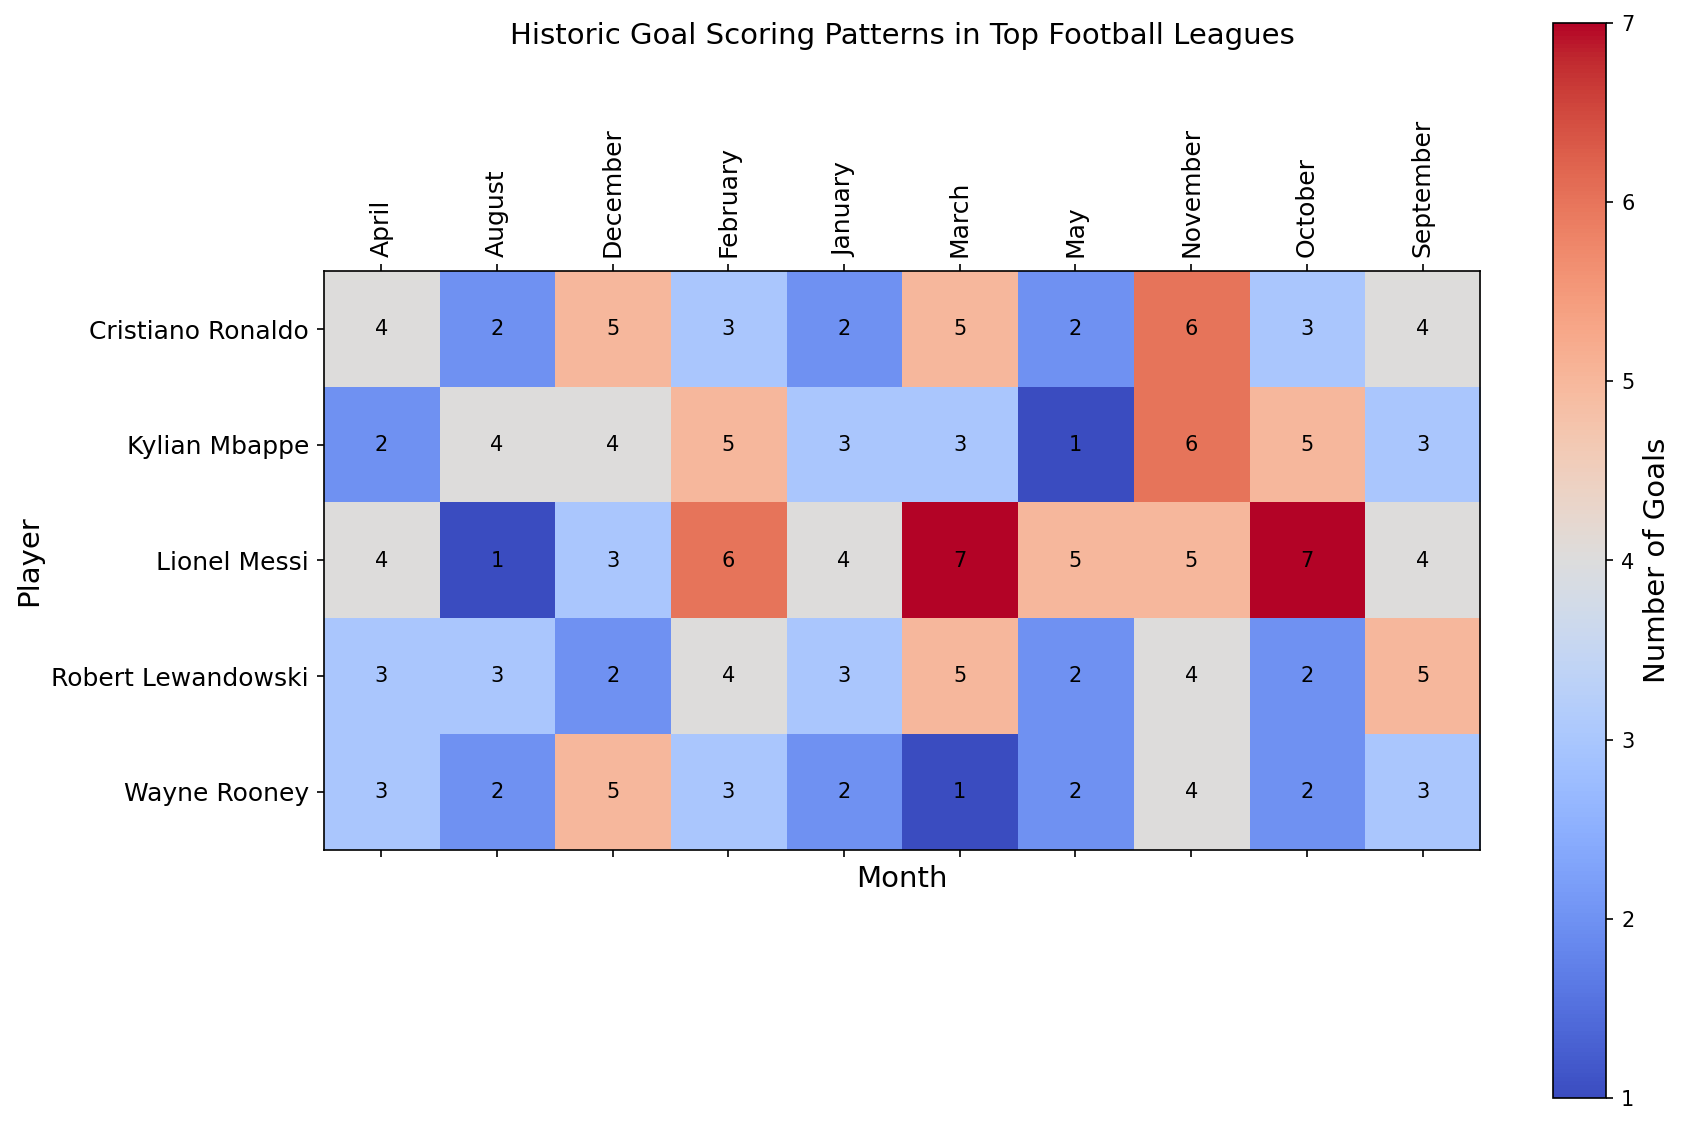Which player scored the most goals in March? According to the heatmap, Lionel Messi of Barcelona scored 7 goals in March, which is the highest among the players.
Answer: Lionel Messi Who had a higher total number of goals in October: Wayne Rooney or Kylian Mbappe? Wayne Rooney scored 2 goals in October, while Kylian Mbappe scored 5 goals in October. Thus, Kylian Mbappe had a higher total number of goals.
Answer: Kylian Mbappe What is the total number of goals scored by Cristiano Ronaldo in November and December combined? Cristiano Ronaldo scored 6 goals in November and 5 goals in December. Adding these values gives 6 + 5 = 11 goals.
Answer: 11 Which player had the highest goal-scoring month across all seasons, and what month was it? Lionel Messi scored 7 goals in both October and March, which are the highest goal-scoring months across all seasons.
Answer: Lionel Messi in October and March What is the comparative difference in goals between Robert Lewandowski and Kylian Mbappe in January? Robert Lewandowski scored 3 goals in January while Kylian Mbappe scored 3 goals as well. The difference is 3 - 3 = 0.
Answer: 0 How does the color intensity of Wayne Rooney’s goal-scoring pattern in February compare to that of Robert Lewandowski in the same month? The color intensity for Wayne Rooney in February indicates 3 goals (darker shade), while Robert Lewandowski's February also shows a similar color intensity for 4 goals (darker shade of red).
Answer: Comparable, both are dark shades In which month did Wayne Rooney score the most goals, and how many did he score? Wayne Rooney scored the most goals in December, with a total of 5 goals.
Answer: December, 5 By how many goals does Lionel Messi’s score in September exceed those of Cristiano Ronaldo in the same month? Lionel Messi scored 4 goals in September, whereas Cristiano Ronaldo scored 4 goals as well. The difference is 4 - 4 = 0.
Answer: 0 Summing up, how many total goals did Robert Lewandowski score during December, January, and February? Robert Lewandowski scored 2 goals in December, 3 goals in January, and 4 goals in February. Summing these gives 2 + 3 + 4 = 9.
Answer: 9 Which player has the most diverse goal-scoring pattern, indicated by a wide range of shades across the months? Lionel Messi's pattern shows a wide range of shades across different months, indicating a highly diverse goal-scoring pattern.
Answer: Lionel Messi 